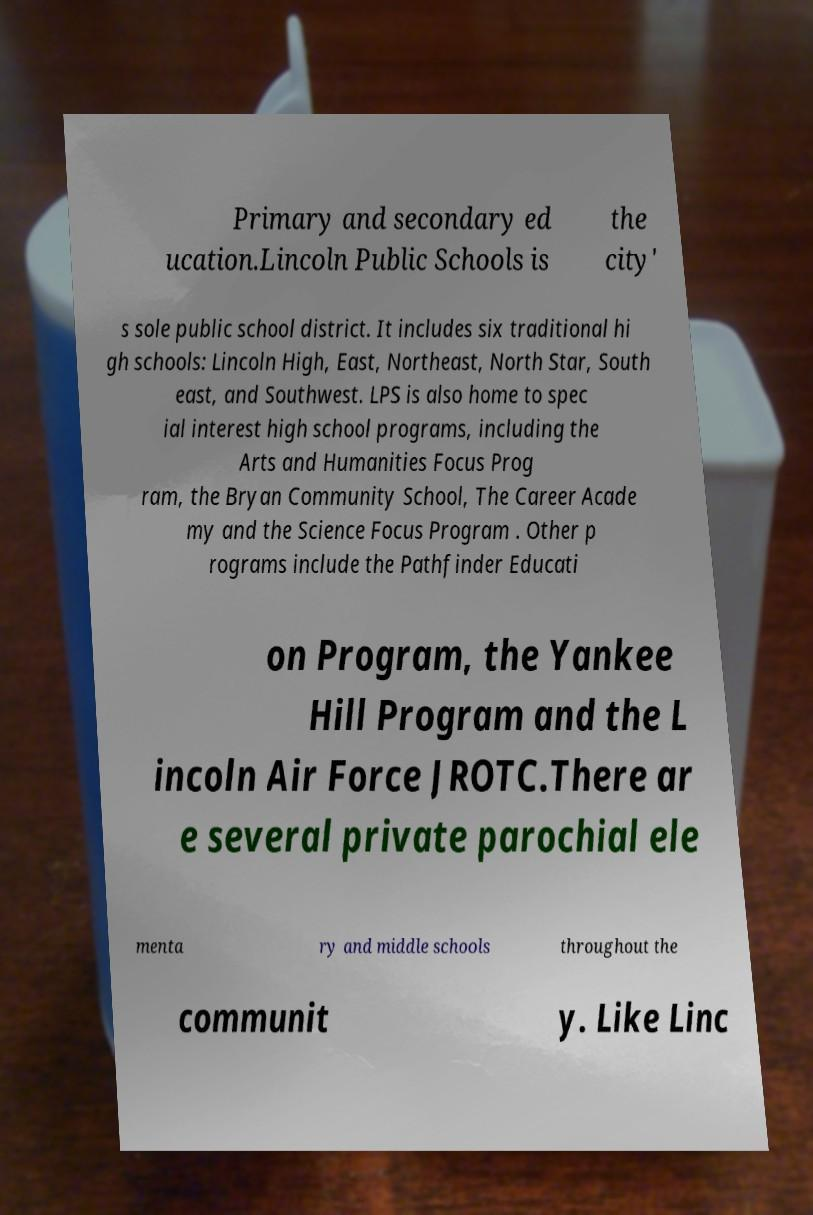Please read and relay the text visible in this image. What does it say? Primary and secondary ed ucation.Lincoln Public Schools is the city' s sole public school district. It includes six traditional hi gh schools: Lincoln High, East, Northeast, North Star, South east, and Southwest. LPS is also home to spec ial interest high school programs, including the Arts and Humanities Focus Prog ram, the Bryan Community School, The Career Acade my and the Science Focus Program . Other p rograms include the Pathfinder Educati on Program, the Yankee Hill Program and the L incoln Air Force JROTC.There ar e several private parochial ele menta ry and middle schools throughout the communit y. Like Linc 